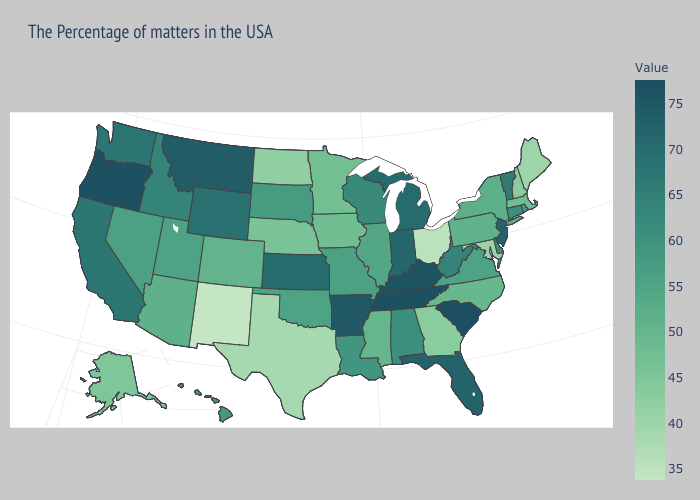Does Wyoming have the lowest value in the West?
Concise answer only. No. Among the states that border Michigan , does Wisconsin have the lowest value?
Write a very short answer. No. Does New Mexico have a lower value than Texas?
Quick response, please. Yes. Among the states that border Utah , does Colorado have the lowest value?
Keep it brief. No. Does Texas have the lowest value in the South?
Answer briefly. Yes. Does Illinois have a lower value than Ohio?
Quick response, please. No. 